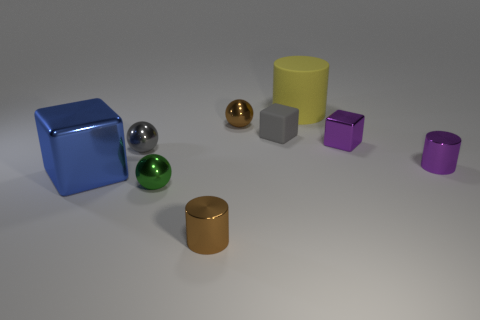Subtract all cylinders. How many objects are left? 6 Subtract 1 yellow cylinders. How many objects are left? 8 Subtract all purple metallic objects. Subtract all green balls. How many objects are left? 6 Add 2 blue cubes. How many blue cubes are left? 3 Add 2 gray metallic objects. How many gray metallic objects exist? 3 